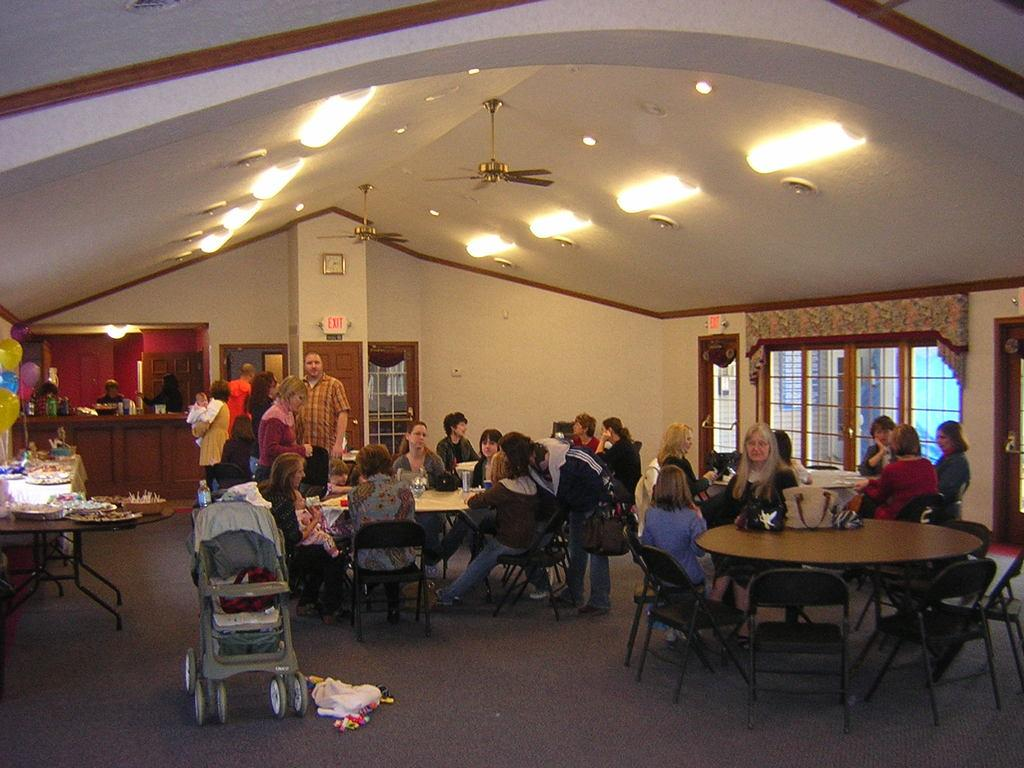What are the people in the image doing? People are seated on chairs in the image. What objects are present for placing items or engaging in activities? Tables are present in the image. What is located in the front of the image? A baby cot is in the front of the image. Where are the balloons situated in the image? Balloons are present at the left corner of the image. What devices are visible at the top of the image? Fans and lights are visible at the top of the image. What is the baby writing on the table in the image? There is no baby writing on the table in the image, as there is no writing or baby engaging in such activity. Who is the creator of the fans visible in the image? The creator of the fans is not mentioned or visible in the image, as it focuses on the objects and their placement. 